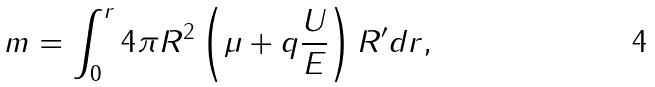Convert formula to latex. <formula><loc_0><loc_0><loc_500><loc_500>m = \int ^ { r } _ { 0 } 4 \pi R ^ { 2 } \left ( \mu + q \frac { U } { E } \right ) R ^ { \prime } d r ,</formula> 